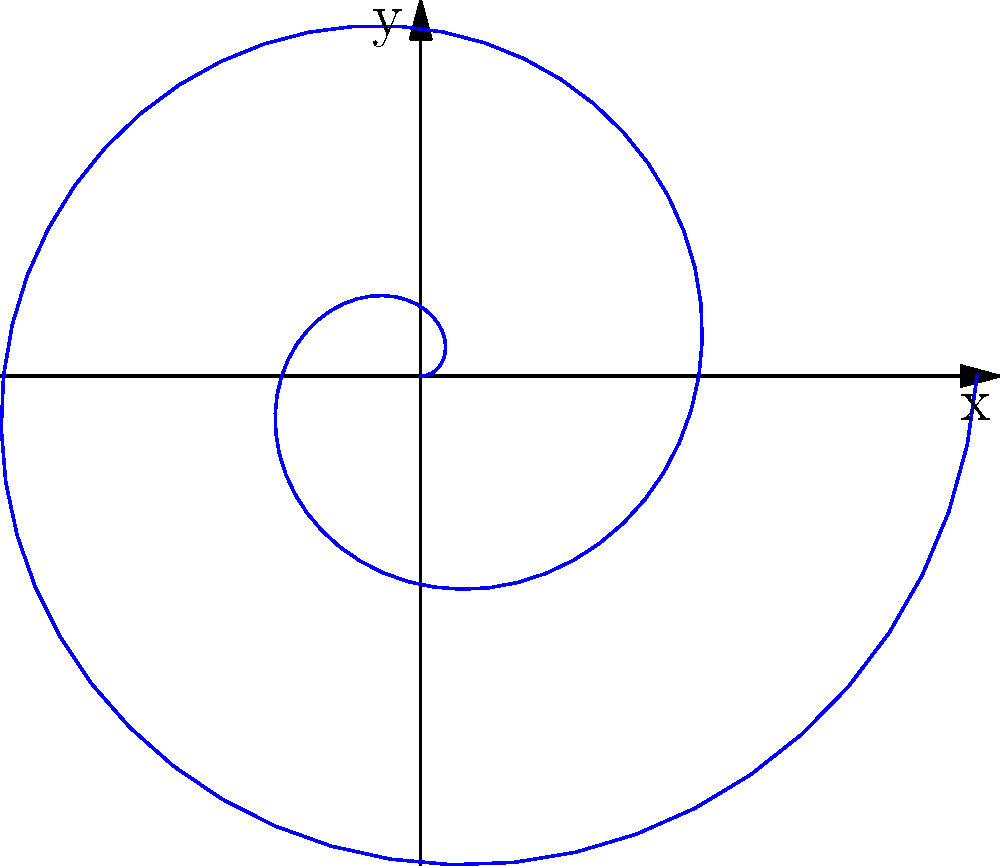In a kinetic art installation, you want to create a spiral pattern using polar coordinates. The spiral is defined by the equation $r = 0.1\theta$, where $r$ is the radius and $\theta$ is the angle in radians. If the installation rotates the spiral through two complete revolutions, what is the maximum radius reached by the spiral? To find the maximum radius of the spiral after two complete revolutions, we need to follow these steps:

1. Recognize that two complete revolutions correspond to an angle of $4\pi$ radians.
   (One revolution = $2\pi$ radians, so two revolutions = $4\pi$ radians)

2. Use the given equation $r = 0.1\theta$ to calculate the radius at $\theta = 4\pi$:

   $r = 0.1 \cdot 4\pi$

3. Simplify the calculation:
   
   $r = 0.4\pi$

4. If needed, we can approximate this value:
   
   $r \approx 1.257$ units

The maximum radius is reached at the end of the two revolutions, which is $0.4\pi$ or approximately 1.257 units.
Answer: $0.4\pi$ units 